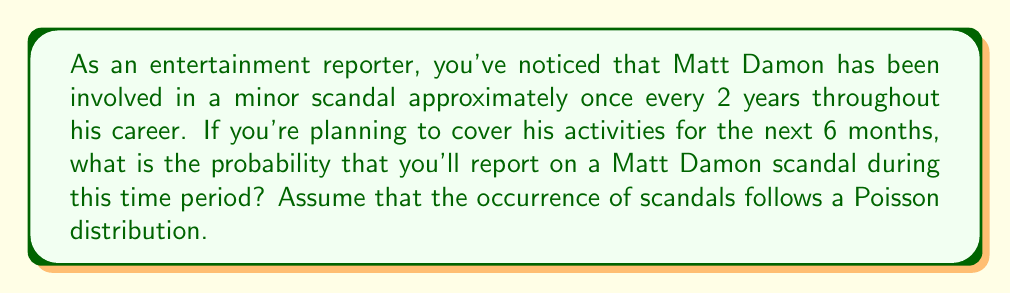Help me with this question. To solve this problem, we'll use the Poisson distribution, which is appropriate for modeling the number of events occurring in a fixed interval of time or space.

Step 1: Calculate the rate parameter (λ) for a 6-month period
- Matt Damon has a scandal once every 2 years on average
- Rate for 1 year = 0.5 scandals/year
- Rate for 6 months (λ) = 0.5 * (6/12) = 0.25 scandals

Step 2: Use the Poisson probability mass function to calculate the probability of at least one scandal
The probability of at least one scandal is the complement of the probability of no scandals.

P(X ≥ 1) = 1 - P(X = 0)

Where P(X = k) is given by the Poisson PMF:

$$ P(X = k) = \frac{e^{-\lambda} \lambda^k}{k!} $$

For k = 0:

$$ P(X = 0) = \frac{e^{-0.25} (0.25)^0}{0!} = e^{-0.25} $$

Step 3: Calculate the final probability
P(X ≥ 1) = 1 - P(X = 0)
          = 1 - e^(-0.25)
          ≈ 1 - 0.7788
          ≈ 0.2212

Therefore, the probability of reporting on a Matt Damon scandal in the next 6 months is approximately 0.2212 or 22.12%.
Answer: $1 - e^{-0.25} \approx 0.2212$ 